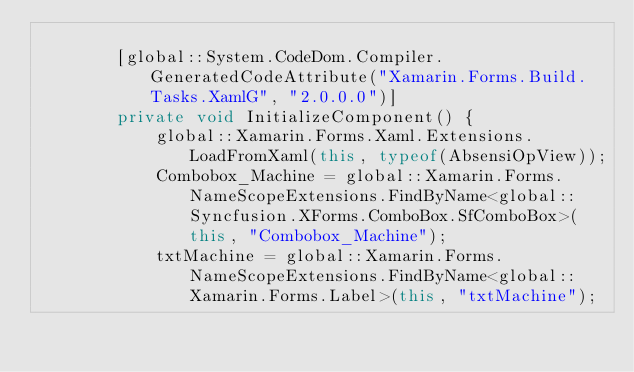Convert code to text. <code><loc_0><loc_0><loc_500><loc_500><_C#_>        
        [global::System.CodeDom.Compiler.GeneratedCodeAttribute("Xamarin.Forms.Build.Tasks.XamlG", "2.0.0.0")]
        private void InitializeComponent() {
            global::Xamarin.Forms.Xaml.Extensions.LoadFromXaml(this, typeof(AbsensiOpView));
            Combobox_Machine = global::Xamarin.Forms.NameScopeExtensions.FindByName<global::Syncfusion.XForms.ComboBox.SfComboBox>(this, "Combobox_Machine");
            txtMachine = global::Xamarin.Forms.NameScopeExtensions.FindByName<global::Xamarin.Forms.Label>(this, "txtMachine");</code> 